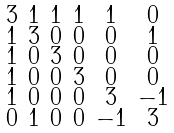<formula> <loc_0><loc_0><loc_500><loc_500>\begin{smallmatrix} 3 & 1 & 1 & 1 & 1 & 0 \\ 1 & 3 & 0 & 0 & 0 & 1 \\ 1 & 0 & 3 & 0 & 0 & 0 \\ 1 & 0 & 0 & 3 & 0 & 0 \\ 1 & 0 & 0 & 0 & 3 & - 1 \\ 0 & 1 & 0 & 0 & - 1 & 3 \end{smallmatrix}</formula> 